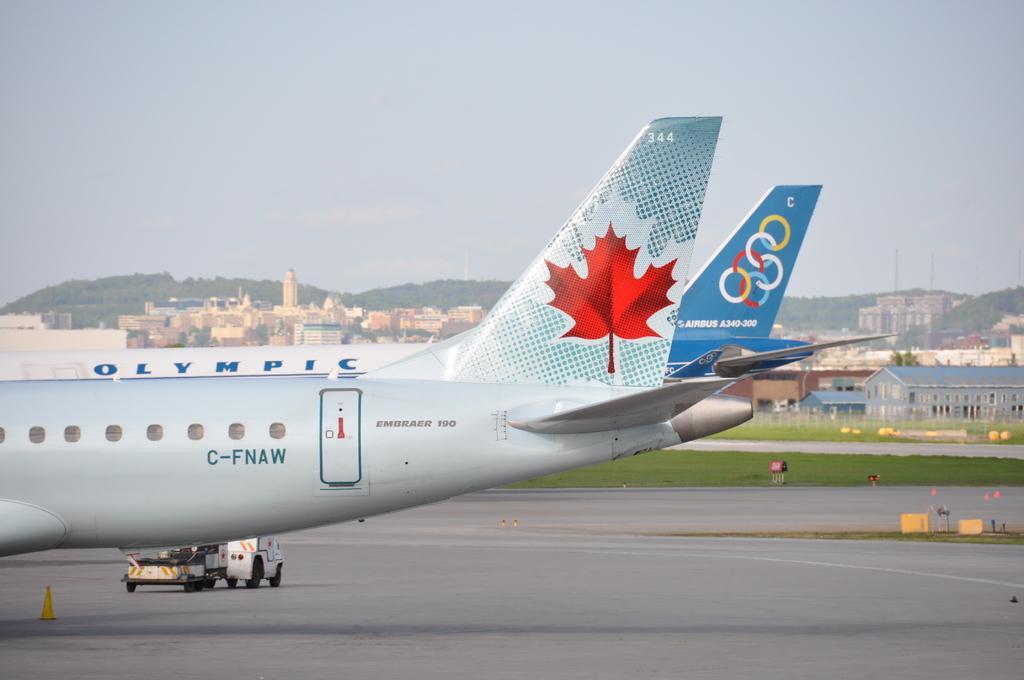How would you summarize this image in a sentence or two? In this image I can see an aircraft's are on the road. These aircrafts are in white and blue color. And I can see the names written on it. I can also see the vehicle on the road. In the back there are sheds, buildings. I can also see the mountains and the sky in the back. 